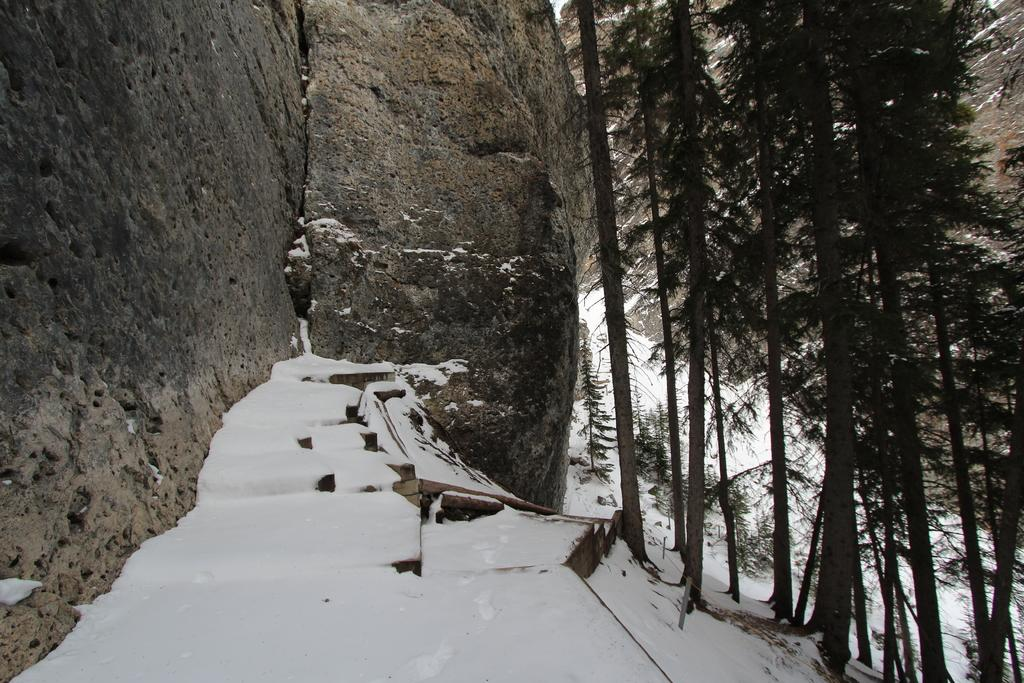What is the predominant weather condition in the image? There is snow in the image, indicating a cold and wintry condition. What geographical features can be seen on the left side of the image? There are mountains on the left side of the image. What type of vegetation is present on the right side of the image? There are trees on the right side of the image. Where is the nearest hospital in the image? There is no hospital present in the image; it features snow, mountains, and trees. What type of flame can be seen burning in the image? There is no flame present in the image. 